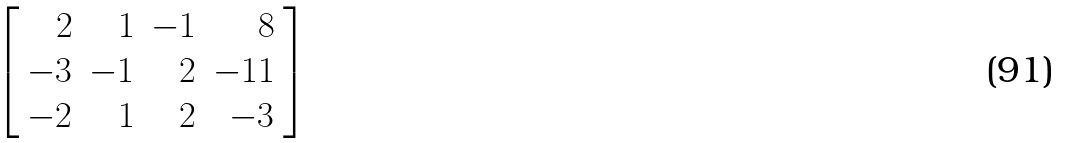<formula> <loc_0><loc_0><loc_500><loc_500>\left [ { \begin{array} { r r r r } { 2 } & { 1 } & { - 1 } & { 8 } \\ { - 3 } & { - 1 } & { 2 } & { - 1 1 } \\ { - 2 } & { 1 } & { 2 } & { - 3 } \end{array} } \right ]</formula> 